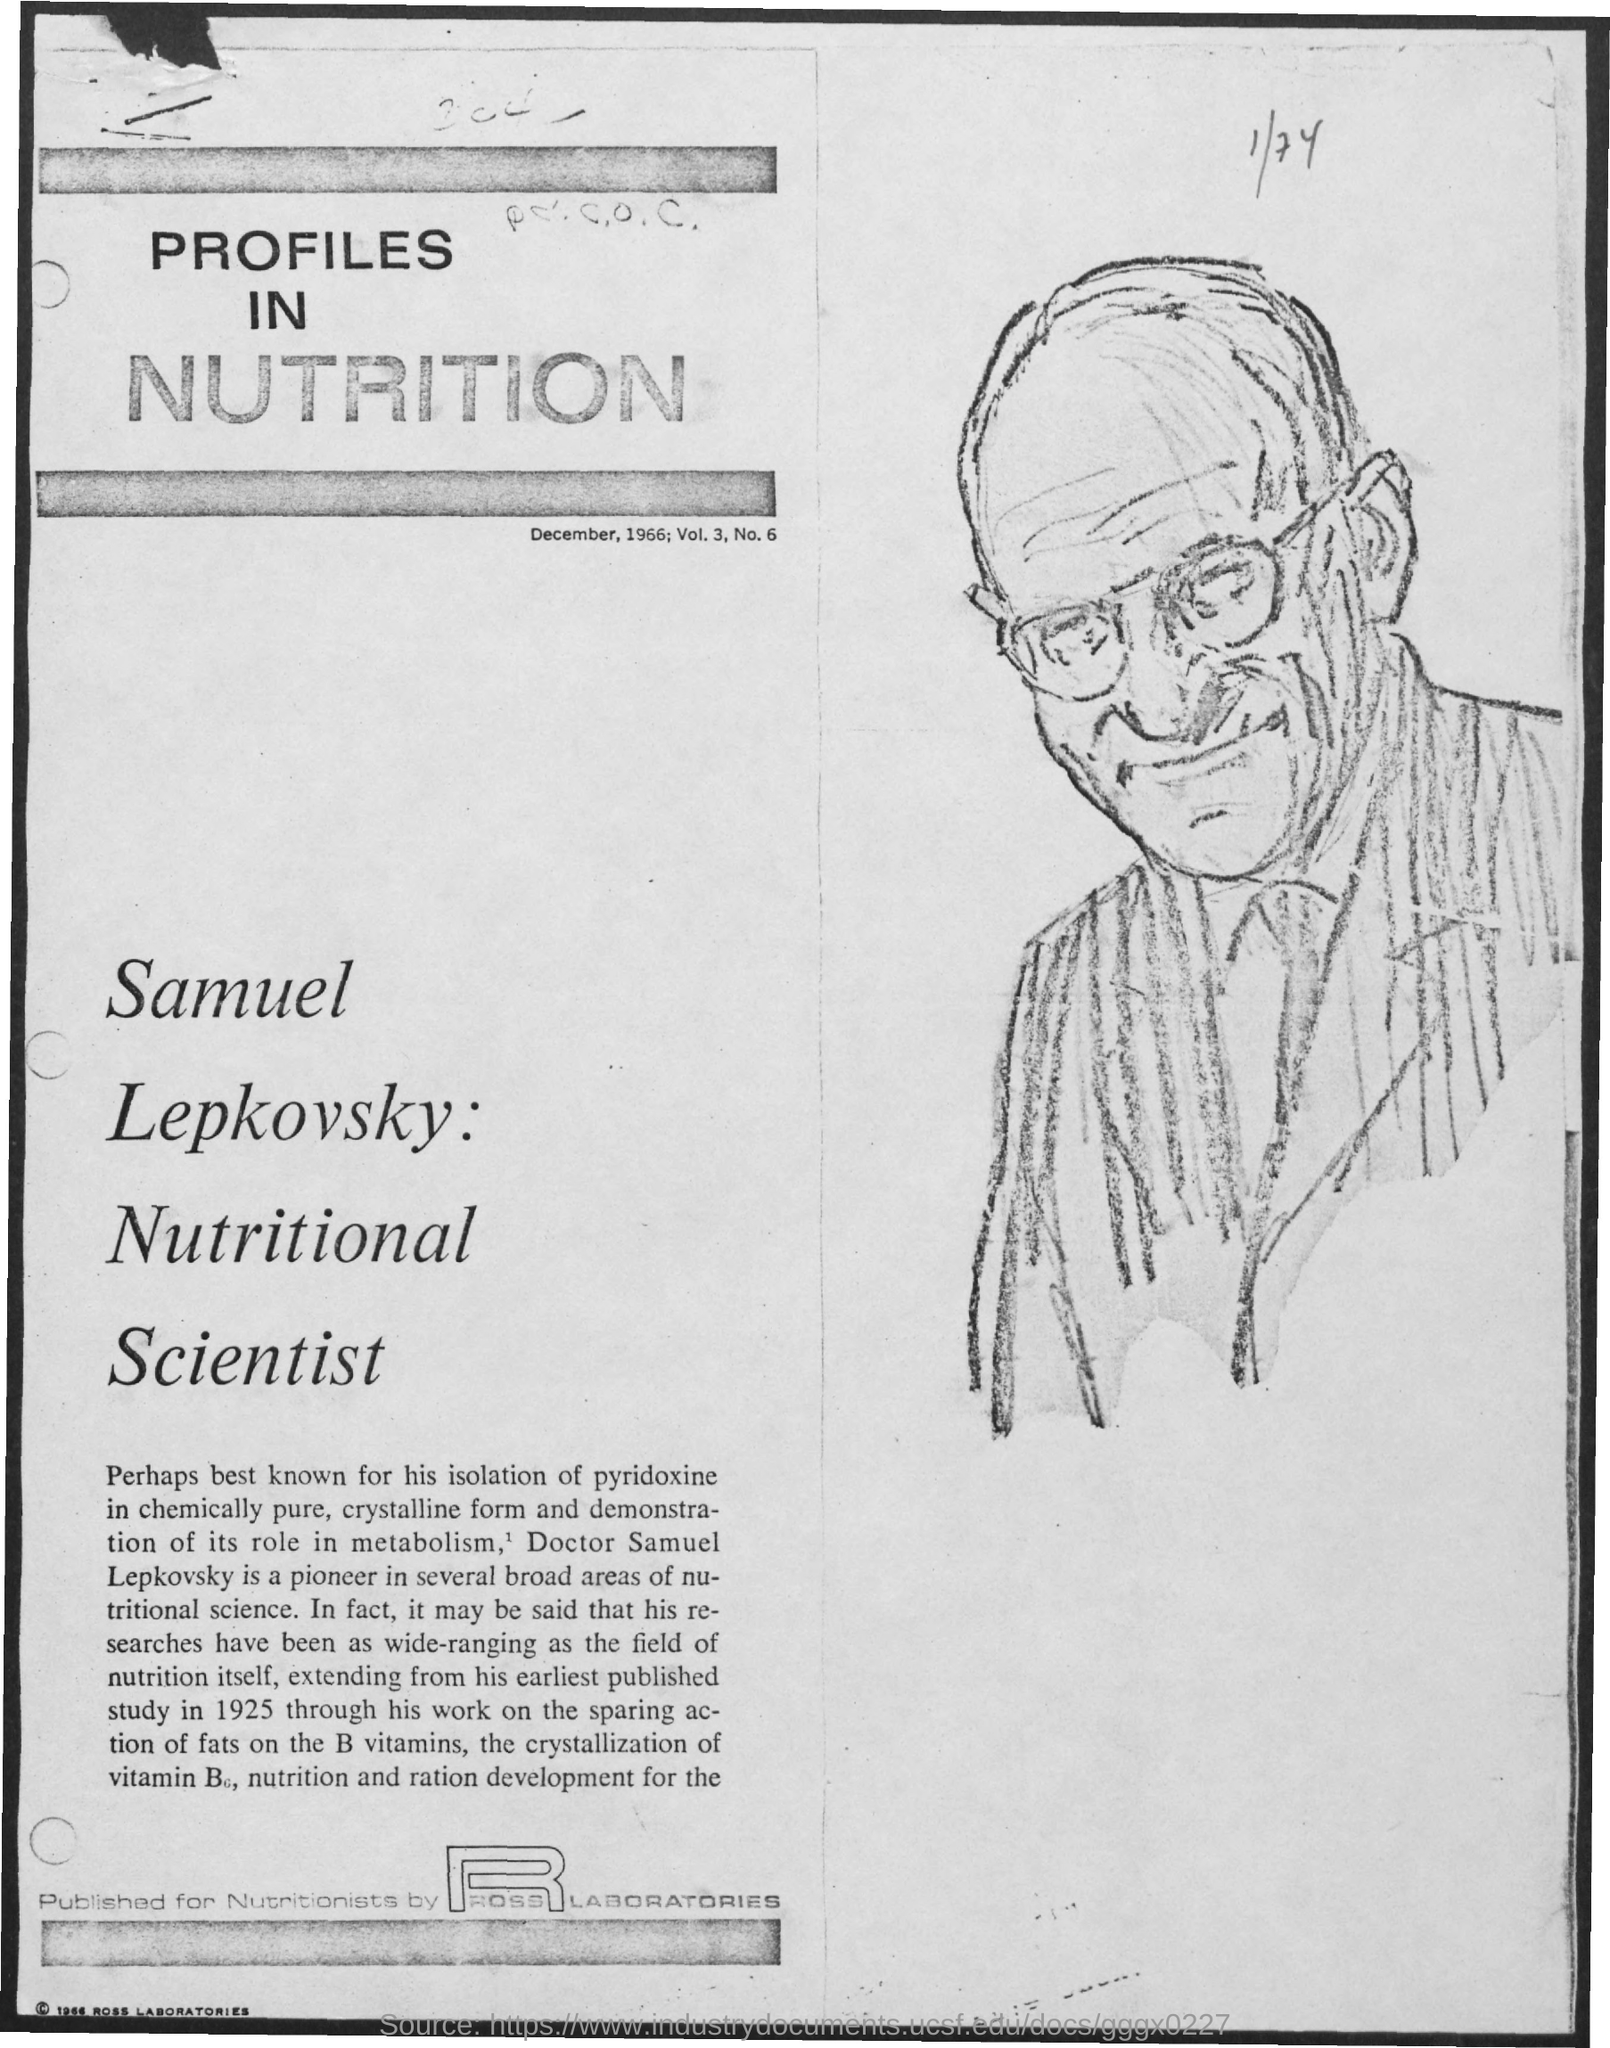Give some essential details in this illustration. The volume is 3... The title of the document is 'Profiles in Nutrition'. The document is dated December, 1966. 